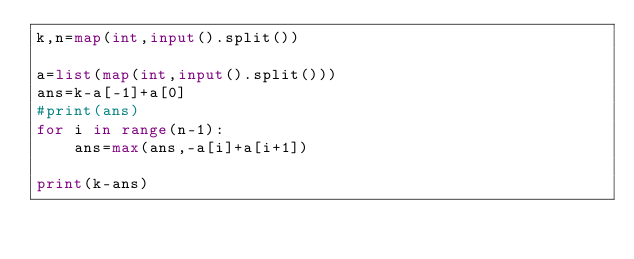<code> <loc_0><loc_0><loc_500><loc_500><_Python_>k,n=map(int,input().split())

a=list(map(int,input().split()))
ans=k-a[-1]+a[0]
#print(ans)
for i in range(n-1):
    ans=max(ans,-a[i]+a[i+1])

print(k-ans)</code> 